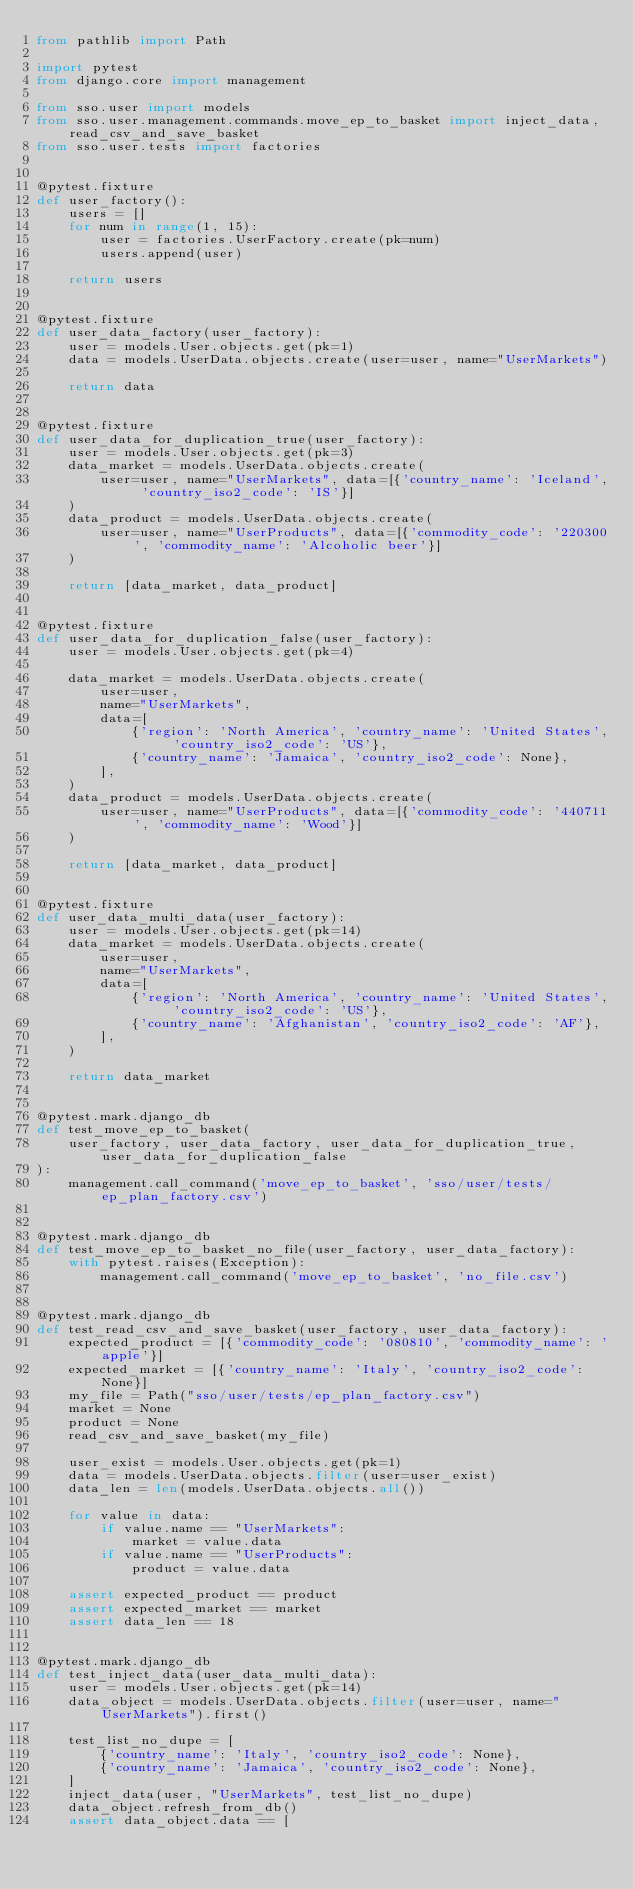<code> <loc_0><loc_0><loc_500><loc_500><_Python_>from pathlib import Path

import pytest
from django.core import management

from sso.user import models
from sso.user.management.commands.move_ep_to_basket import inject_data, read_csv_and_save_basket
from sso.user.tests import factories


@pytest.fixture
def user_factory():
    users = []
    for num in range(1, 15):
        user = factories.UserFactory.create(pk=num)
        users.append(user)

    return users


@pytest.fixture
def user_data_factory(user_factory):
    user = models.User.objects.get(pk=1)
    data = models.UserData.objects.create(user=user, name="UserMarkets")

    return data


@pytest.fixture
def user_data_for_duplication_true(user_factory):
    user = models.User.objects.get(pk=3)
    data_market = models.UserData.objects.create(
        user=user, name="UserMarkets", data=[{'country_name': 'Iceland', 'country_iso2_code': 'IS'}]
    )
    data_product = models.UserData.objects.create(
        user=user, name="UserProducts", data=[{'commodity_code': '220300', 'commodity_name': 'Alcoholic beer'}]
    )

    return [data_market, data_product]


@pytest.fixture
def user_data_for_duplication_false(user_factory):
    user = models.User.objects.get(pk=4)

    data_market = models.UserData.objects.create(
        user=user,
        name="UserMarkets",
        data=[
            {'region': 'North America', 'country_name': 'United States', 'country_iso2_code': 'US'},
            {'country_name': 'Jamaica', 'country_iso2_code': None},
        ],
    )
    data_product = models.UserData.objects.create(
        user=user, name="UserProducts", data=[{'commodity_code': '440711', 'commodity_name': 'Wood'}]
    )

    return [data_market, data_product]


@pytest.fixture
def user_data_multi_data(user_factory):
    user = models.User.objects.get(pk=14)
    data_market = models.UserData.objects.create(
        user=user,
        name="UserMarkets",
        data=[
            {'region': 'North America', 'country_name': 'United States', 'country_iso2_code': 'US'},
            {'country_name': 'Afghanistan', 'country_iso2_code': 'AF'},
        ],
    )

    return data_market


@pytest.mark.django_db
def test_move_ep_to_basket(
    user_factory, user_data_factory, user_data_for_duplication_true, user_data_for_duplication_false
):
    management.call_command('move_ep_to_basket', 'sso/user/tests/ep_plan_factory.csv')


@pytest.mark.django_db
def test_move_ep_to_basket_no_file(user_factory, user_data_factory):
    with pytest.raises(Exception):
        management.call_command('move_ep_to_basket', 'no_file.csv')


@pytest.mark.django_db
def test_read_csv_and_save_basket(user_factory, user_data_factory):
    expected_product = [{'commodity_code': '080810', 'commodity_name': 'apple'}]
    expected_market = [{'country_name': 'Italy', 'country_iso2_code': None}]
    my_file = Path("sso/user/tests/ep_plan_factory.csv")
    market = None
    product = None
    read_csv_and_save_basket(my_file)

    user_exist = models.User.objects.get(pk=1)
    data = models.UserData.objects.filter(user=user_exist)
    data_len = len(models.UserData.objects.all())

    for value in data:
        if value.name == "UserMarkets":
            market = value.data
        if value.name == "UserProducts":
            product = value.data

    assert expected_product == product
    assert expected_market == market
    assert data_len == 18


@pytest.mark.django_db
def test_inject_data(user_data_multi_data):
    user = models.User.objects.get(pk=14)
    data_object = models.UserData.objects.filter(user=user, name="UserMarkets").first()

    test_list_no_dupe = [
        {'country_name': 'Italy', 'country_iso2_code': None},
        {'country_name': 'Jamaica', 'country_iso2_code': None},
    ]
    inject_data(user, "UserMarkets", test_list_no_dupe)
    data_object.refresh_from_db()
    assert data_object.data == [</code> 